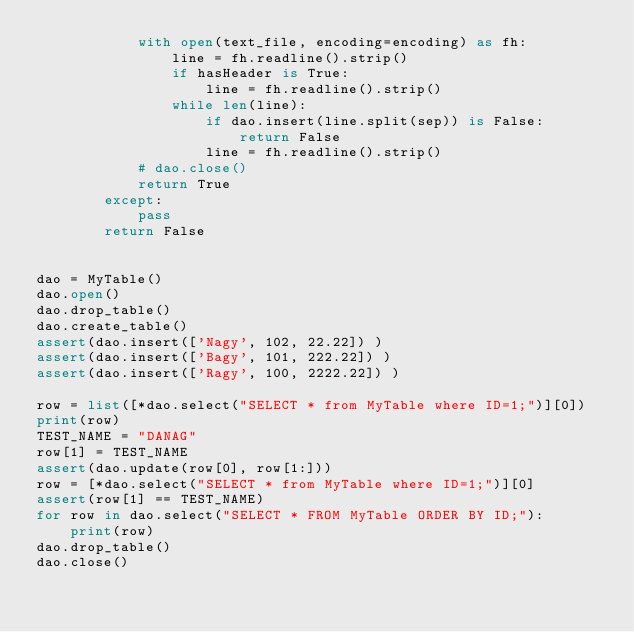Convert code to text. <code><loc_0><loc_0><loc_500><loc_500><_Python_>            with open(text_file, encoding=encoding) as fh:
                line = fh.readline().strip()
                if hasHeader is True:
                    line = fh.readline().strip()
                while len(line):
                    if dao.insert(line.split(sep)) is False:
                        return False
                    line = fh.readline().strip()
            # dao.close()
            return True
        except:
            pass
        return False
        
    
dao = MyTable()
dao.open()
dao.drop_table()
dao.create_table()
assert(dao.insert(['Nagy', 102, 22.22]) )
assert(dao.insert(['Bagy', 101, 222.22]) )
assert(dao.insert(['Ragy', 100, 2222.22]) )

row = list([*dao.select("SELECT * from MyTable where ID=1;")][0])
print(row)
TEST_NAME = "DANAG"
row[1] = TEST_NAME
assert(dao.update(row[0], row[1:]))
row = [*dao.select("SELECT * from MyTable where ID=1;")][0]
assert(row[1] == TEST_NAME)
for row in dao.select("SELECT * FROM MyTable ORDER BY ID;"):
    print(row)
dao.drop_table()
dao.close()

</code> 